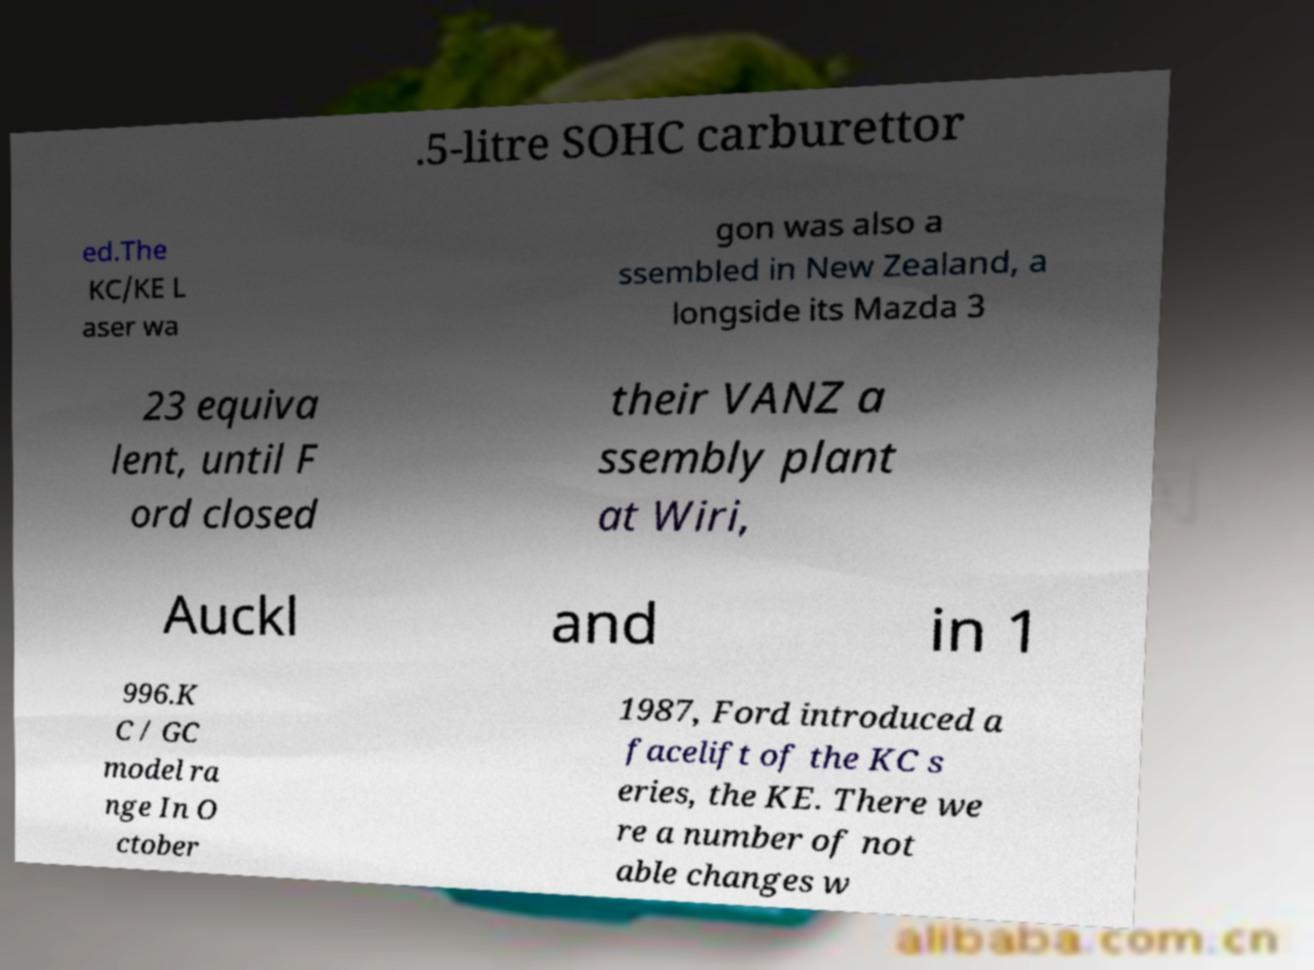Can you read and provide the text displayed in the image?This photo seems to have some interesting text. Can you extract and type it out for me? .5-litre SOHC carburettor ed.The KC/KE L aser wa gon was also a ssembled in New Zealand, a longside its Mazda 3 23 equiva lent, until F ord closed their VANZ a ssembly plant at Wiri, Auckl and in 1 996.K C / GC model ra nge In O ctober 1987, Ford introduced a facelift of the KC s eries, the KE. There we re a number of not able changes w 